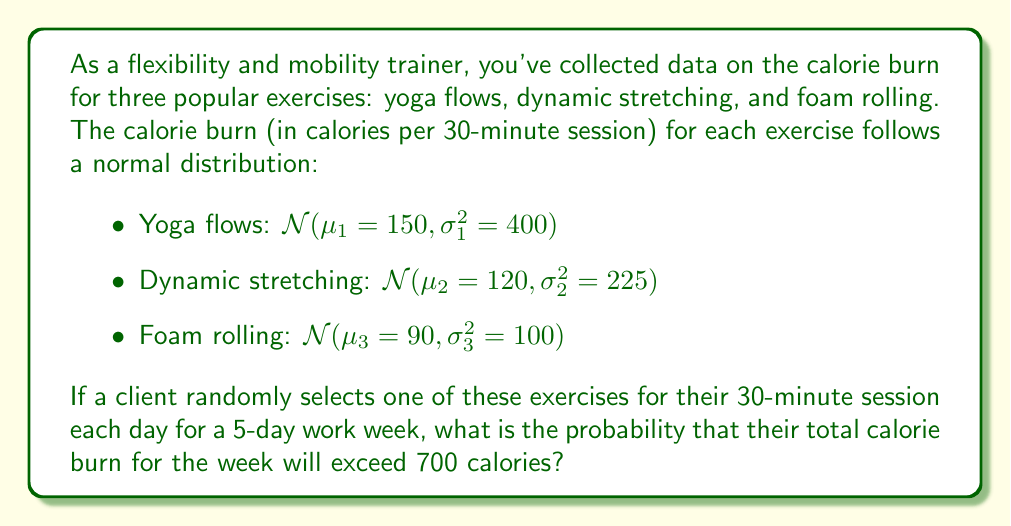Help me with this question. Let's approach this step-by-step:

1) First, we need to find the distribution of the total calorie burn for the week. Let X be this random variable.

2) X is the sum of 5 independent random variables, each representing the calorie burn for one day. Each day's exercise is randomly chosen from the three options.

3) The mean of X will be the average of the means of the three exercises, multiplied by 5:
   $$\mu_X = 5 \cdot \frac{\mu_1 + \mu_2 + \mu_3}{3} = 5 \cdot \frac{150 + 120 + 90}{3} = 600$$

4) The variance of X will be the average of the variances of the three exercises, multiplied by 5:
   $$\sigma_X^2 = 5 \cdot \frac{\sigma_1^2 + \sigma_2^2 + \sigma_3^2}{3} = 5 \cdot \frac{400 + 225 + 100}{3} = 1208.33$$

5) The standard deviation of X is:
   $$\sigma_X = \sqrt{1208.33} \approx 34.76$$

6) By the Central Limit Theorem, X will be approximately normally distributed:
   $$X \sim \mathcal{N}(600, 1208.33)$$

7) We want to find P(X > 700). We can standardize this:
   $$P(X > 700) = P\left(\frac{X - \mu_X}{\sigma_X} > \frac{700 - 600}{34.76}\right) = P(Z > 2.88)$$

8) Using a standard normal table or calculator, we can find:
   $$P(Z > 2.88) \approx 0.002$$

Therefore, the probability that the total calorie burn for the week will exceed 700 calories is approximately 0.002 or 0.2%.
Answer: 0.002 